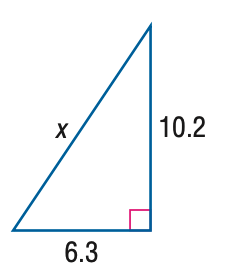Question: Find x.
Choices:
A. 11.0
B. 11.5
C. 12.0
D. 12.5
Answer with the letter. Answer: C 